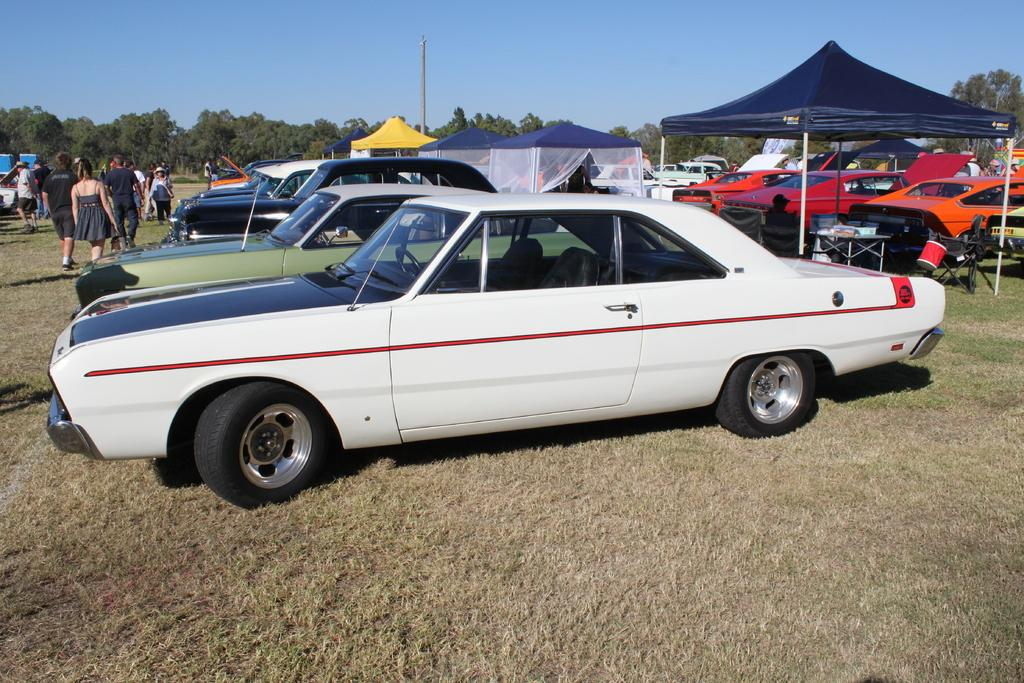What type of vehicles can be seen in the image? There are cars in the image. What are the people on the ground doing? There is a group of people on the ground, but their activity is not specified in the facts. What structure is present in the image? There is a pole in the image. What type of temporary shelter is visible in the image? There are tents in the image. What type of vegetation is present in the image? There are trees in the image. What is visible in the background of the image? The sky is visible in the background of the image. How many girls are sailing on the grass in the image? There are no girls sailing on the grass in the image, as there is no grass or sailing activity mentioned in the facts. 